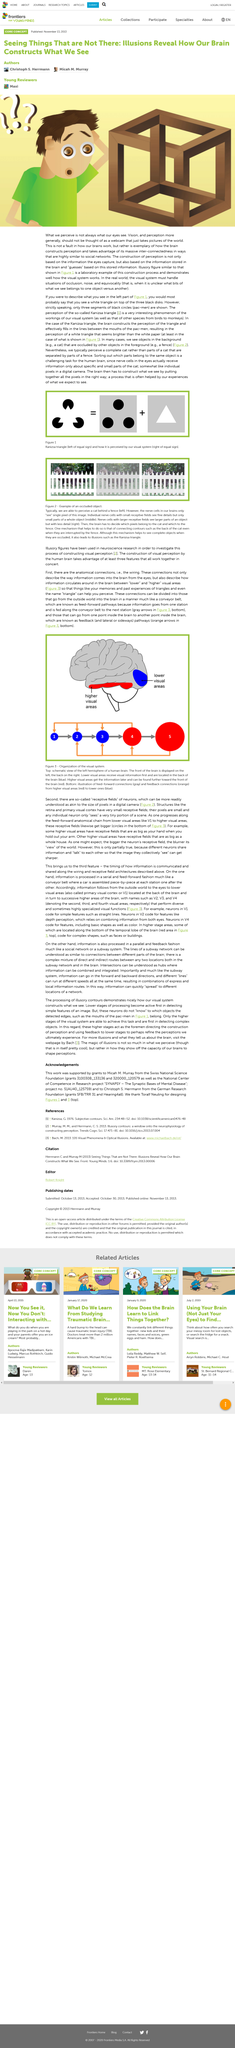Specify some key components in this picture. The construction of perception is not the only thing that is based on the information the eyes capture. Figures 1 and 3 were designed by Toralf Neuling. Is what we perceive what our eyes see? No, what we perceive is not always what our eyes see. The Swiss National Science Foundation is from Switzerland, and Micah M. Murray is from there too. This work was supported by grants awarded to Micah M. Murray. 